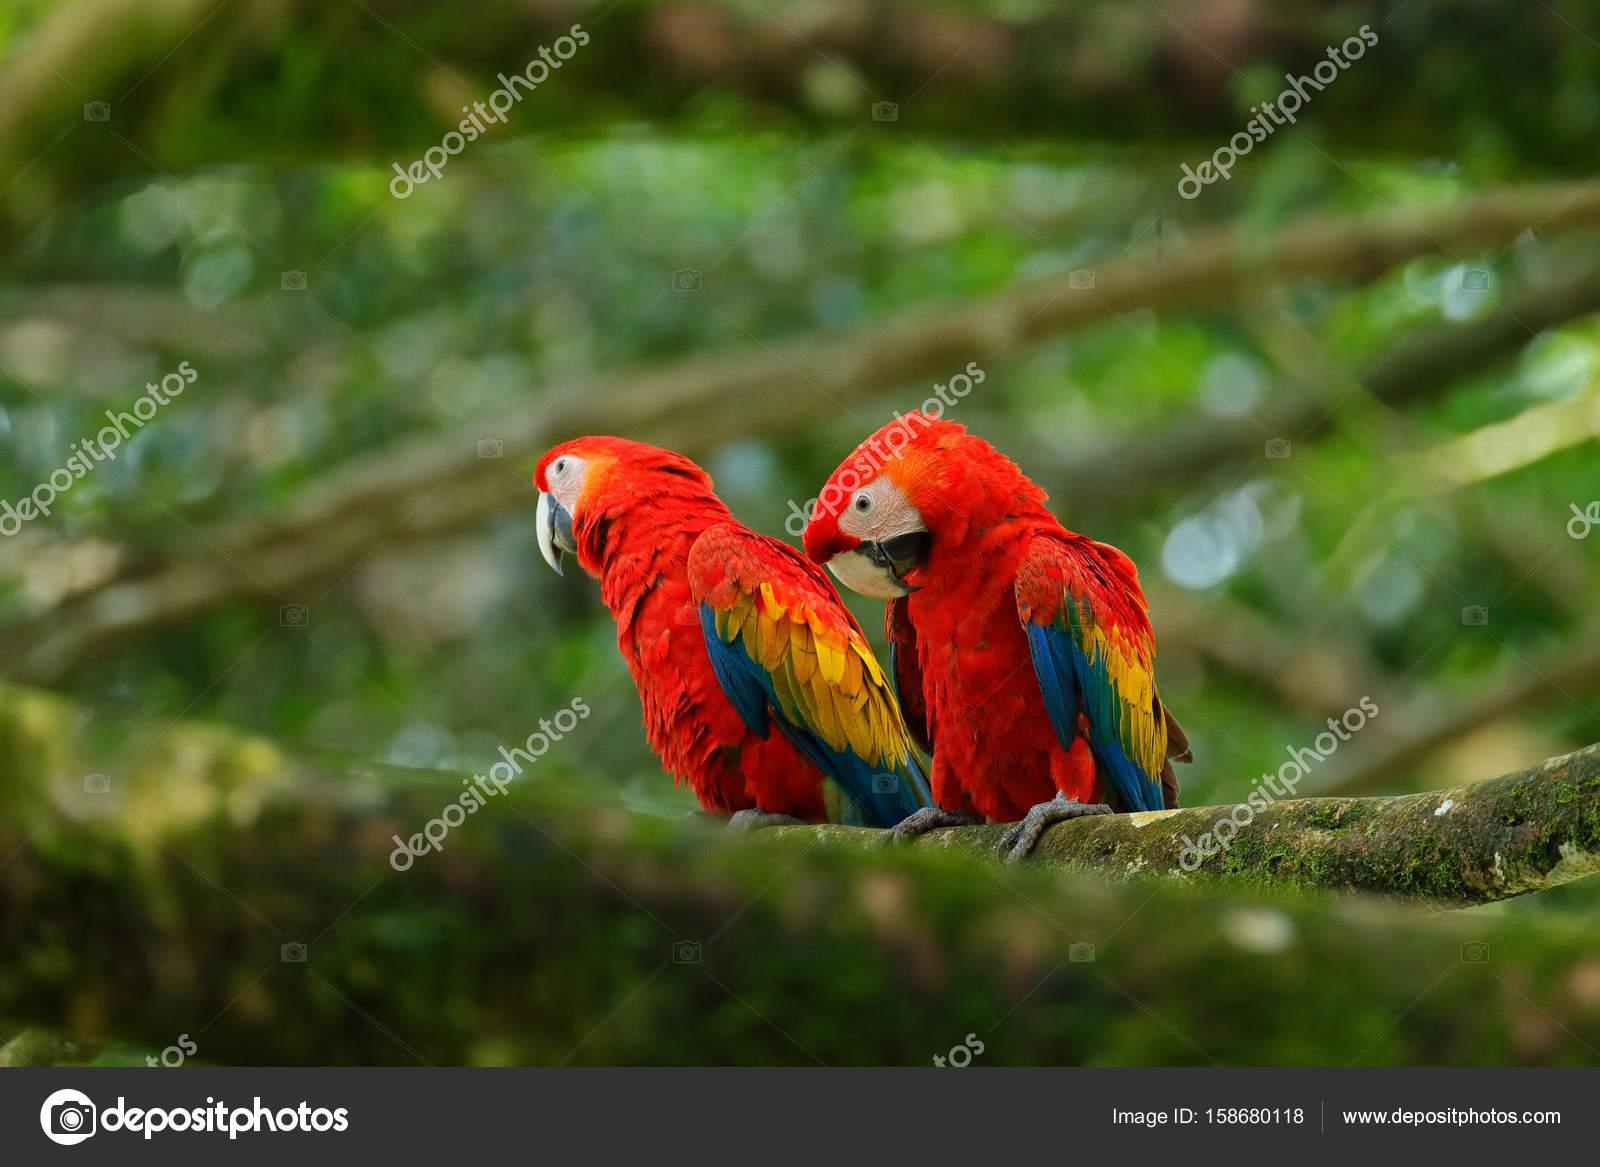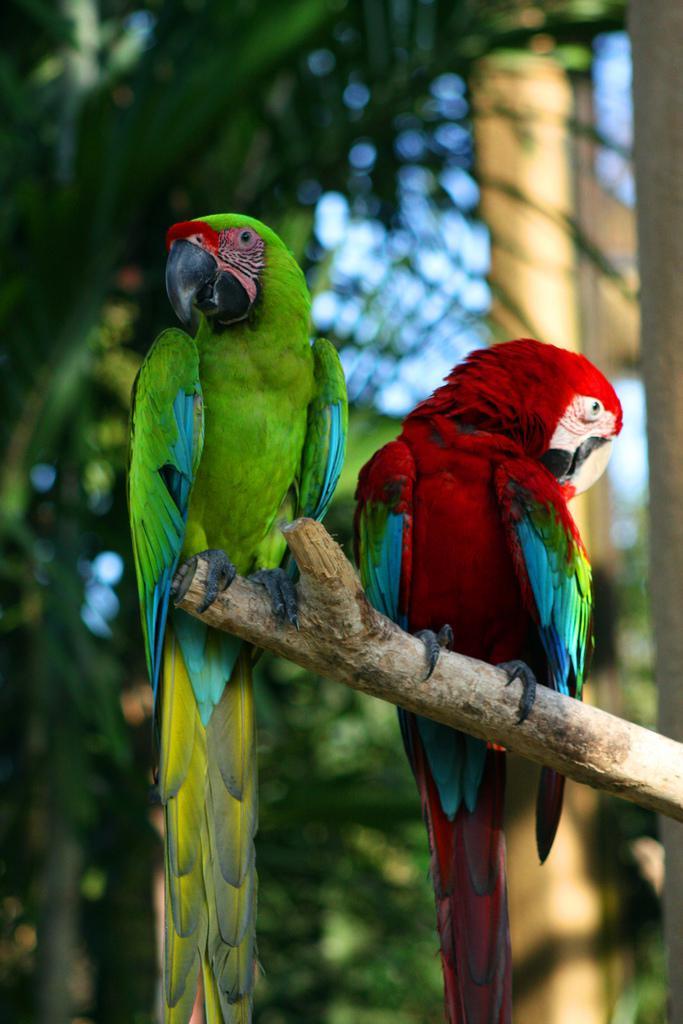The first image is the image on the left, the second image is the image on the right. For the images displayed, is the sentence "The combined images contain no more than four parrots, and include a parrot with a green head and body." factually correct? Answer yes or no. Yes. The first image is the image on the left, the second image is the image on the right. Analyze the images presented: Is the assertion "The right image contains exactly two parrots." valid? Answer yes or no. Yes. 